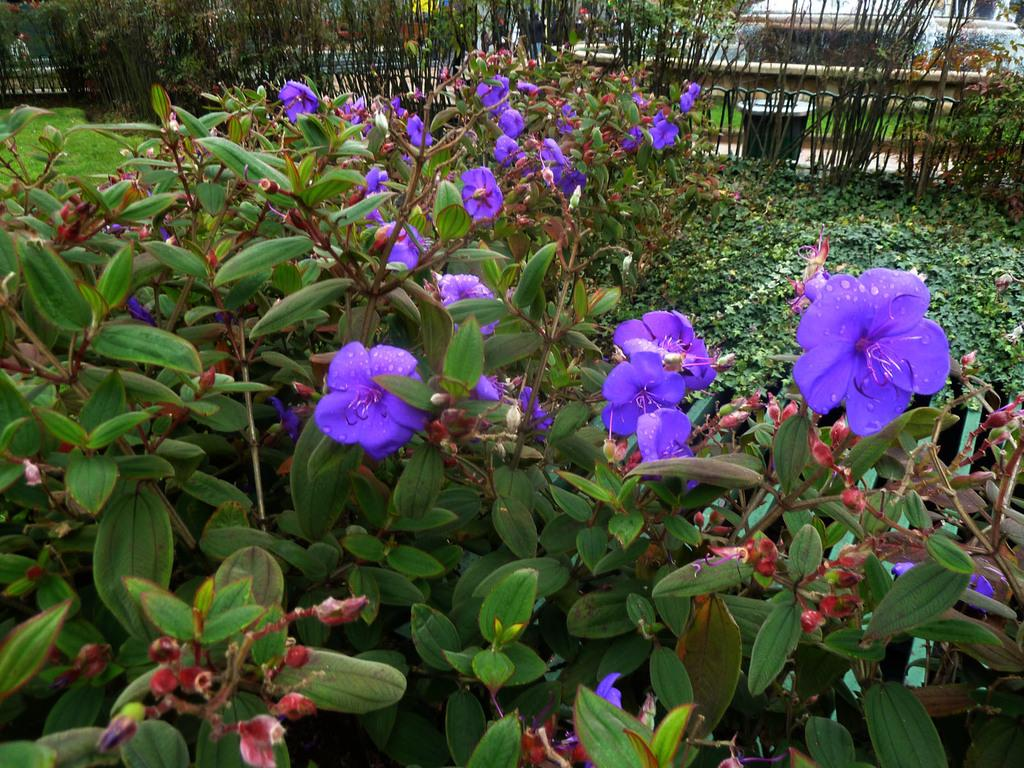What type of plants can be seen in the image? There are flower plants in the image. What can be seen in the background of the image? There is a fence, a wall, and a dustbin in the background of the image. Can you describe the person in the image? There is a person in the top left corner of the image. What type of stone is the person using to pay their taxes in the image? There is no stone or reference to taxes in the image; it features flower plants, a fence, a wall, a dustbin, and a person. 